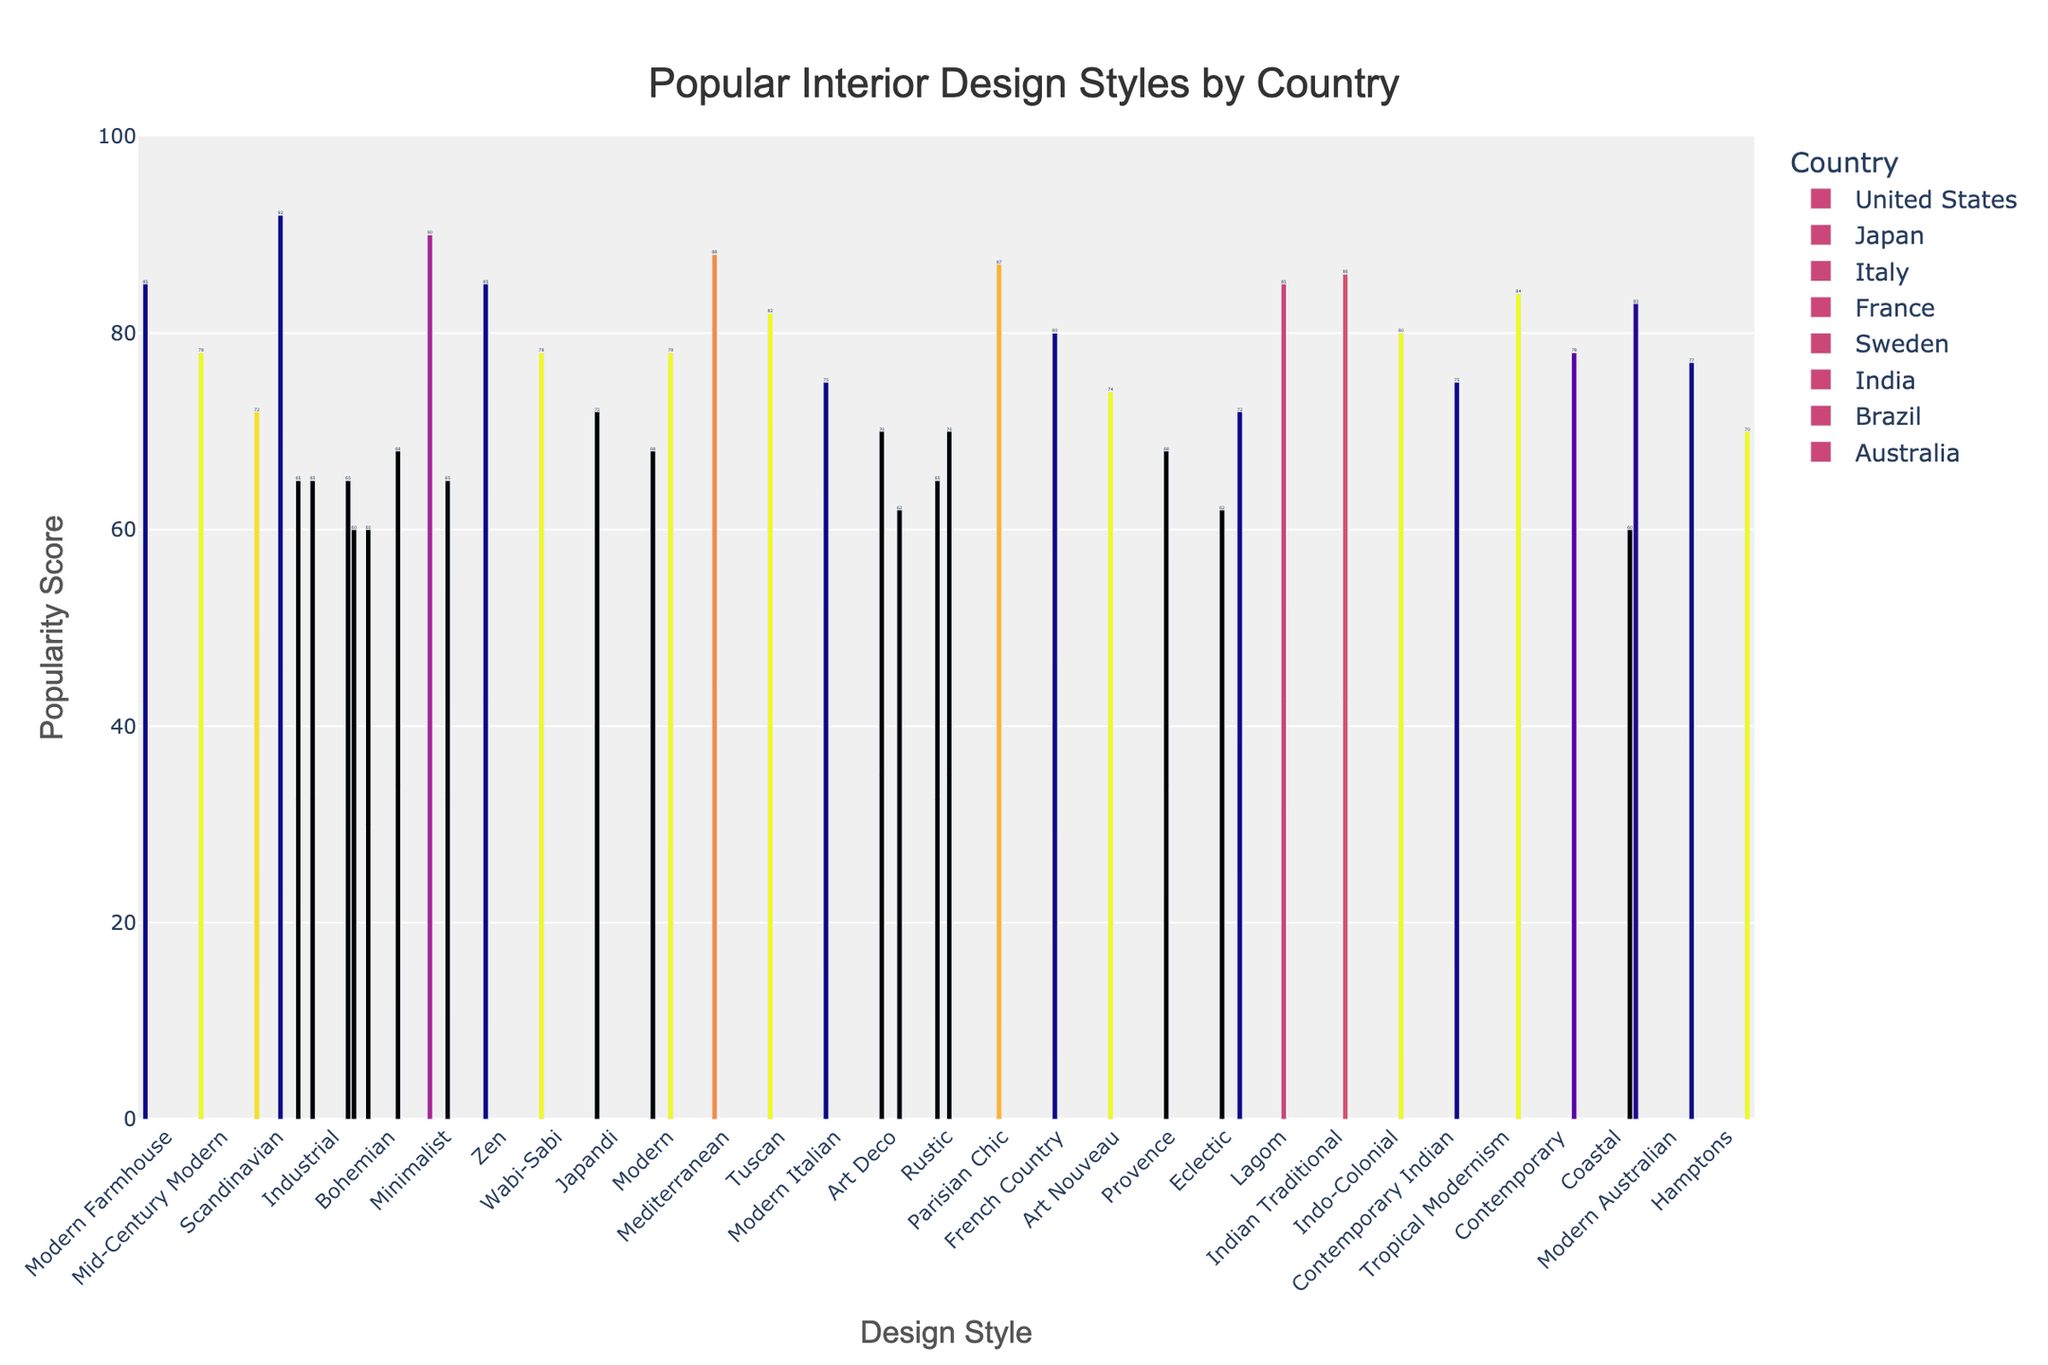What’s the most popular interior design style in Japan? From the chart, the bar representing Japan under the style "Minimalist" is the highest. This indicates that "Minimalist" has the highest popularity score in Japan.
Answer: Minimalist Which country has the highest popularity score for the "Industrial" style? Look for the bars labeled "Industrial" for all countries. The United States has the highest bar for "Industrial" style with a score of 65.
Answer: United States How does the popularity of "Bohemian" style in the United States compare to that in India? Compare the heights of the bars for "Bohemian" style in the United States and India. The United States has a score of 60 while India has a score of 68, making it more popular in India.
Answer: More popular in India What is the average popularity score of the top 5 styles in Italy? The scores for Italy are Mediterranean (88), Tuscan (82), Modern Italian (75), Art Deco (70), and Rustic (65). The average is calculated as (88 + 82 + 75 + 70 + 65) / 5 = 380 / 5 = 76.
Answer: 76 Which country has the most diverse range of top styles in terms of popularity scores? Look for the country with the widest range between the highest and lowest scores among its top styles. Japan's scores range from 90 (Minimalist) to 68 (Modern), giving it a range of 22. This is greater than any other country.
Answer: Japan What is the difference in popularity between "Scandinavian" style in Sweden and the United States? "Scandinavian" style has a popularity score of 92 in Sweden and 72 in the United States. The difference is 92 - 72 = 20.
Answer: 20 Which country listed has coastal-inspired design as one of its top 5 styles? Look for bars labeled "Coastal." Brazil and Australia both list "Coastal" as one of their top 5 styles.
Answer: Brazil and Australia Is "Modern" style equally popular in the United States and Sweden? Compare the heights of the bars for "Modern" style in both the United States and Sweden. The score is 68 in Japan and 78 in Sweden, showing it is not equally popular.
Answer: No What’s the least popular style in France among the top 5 shown? Check the labels for France and find the bar with the lowest height among its top 5 styles. The least popular style is "Eclectic" with a score of 62.
Answer: Eclectic Which country favors a predominantly nature-related design style? Compare the names of the top styles for all the countries and their general themes. Japan with its top styles like "Minimalist", "Zen", and "Wabi-Sabi" reflects a nature-inspired approach.
Answer: Japan 